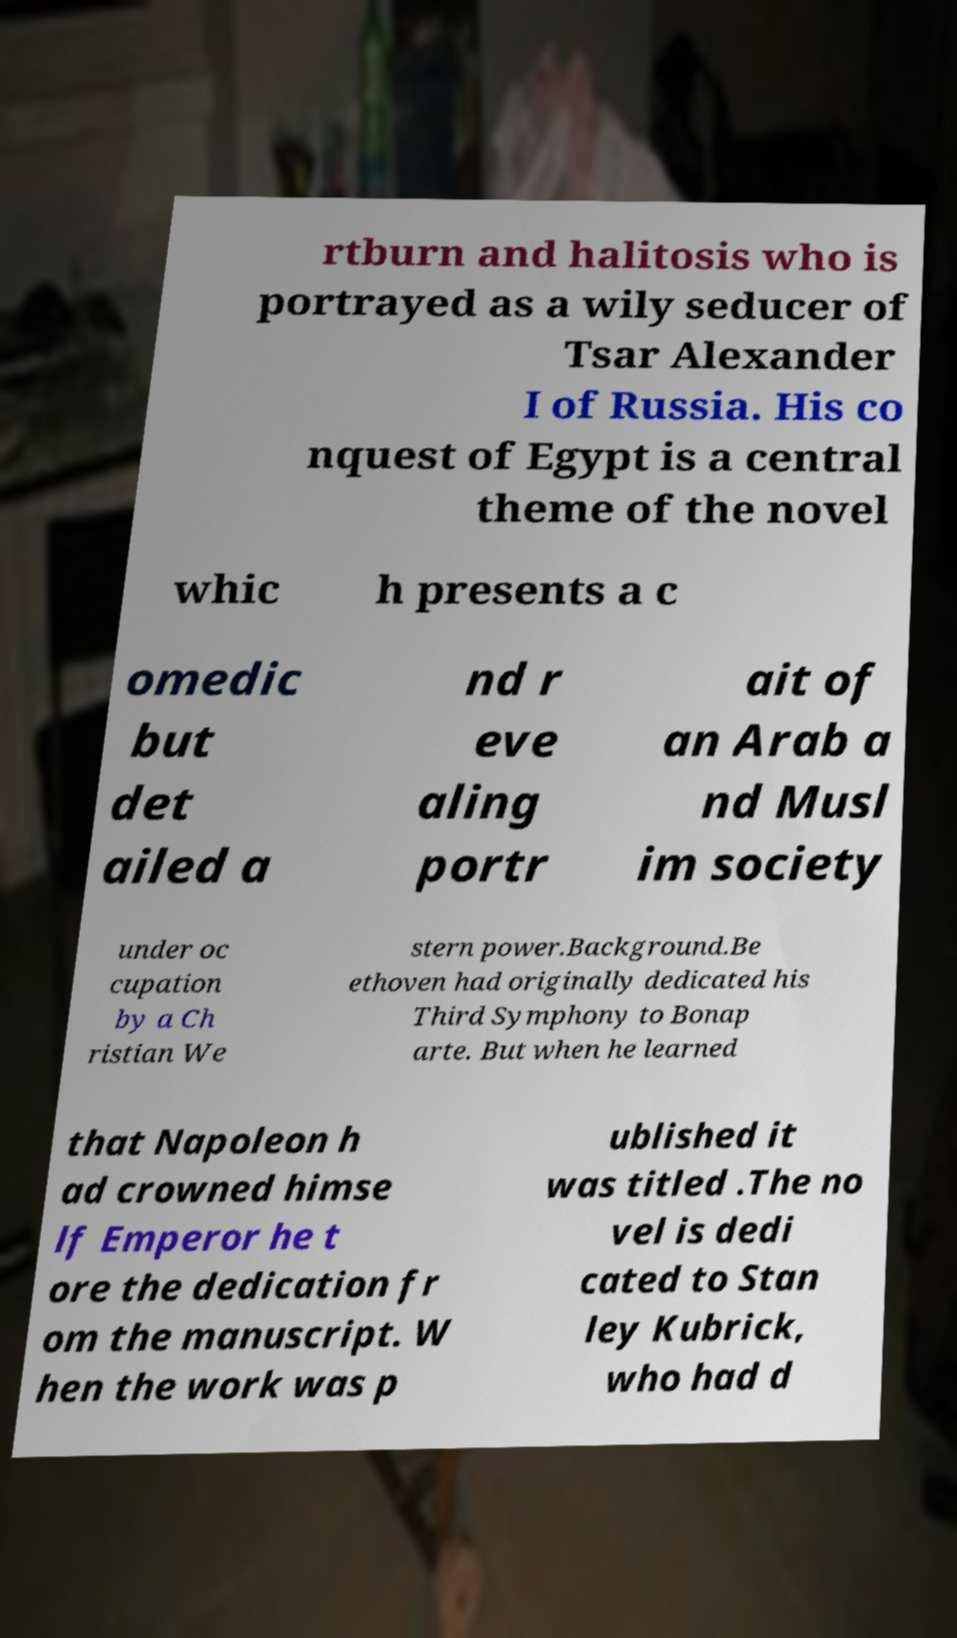I need the written content from this picture converted into text. Can you do that? rtburn and halitosis who is portrayed as a wily seducer of Tsar Alexander I of Russia. His co nquest of Egypt is a central theme of the novel whic h presents a c omedic but det ailed a nd r eve aling portr ait of an Arab a nd Musl im society under oc cupation by a Ch ristian We stern power.Background.Be ethoven had originally dedicated his Third Symphony to Bonap arte. But when he learned that Napoleon h ad crowned himse lf Emperor he t ore the dedication fr om the manuscript. W hen the work was p ublished it was titled .The no vel is dedi cated to Stan ley Kubrick, who had d 